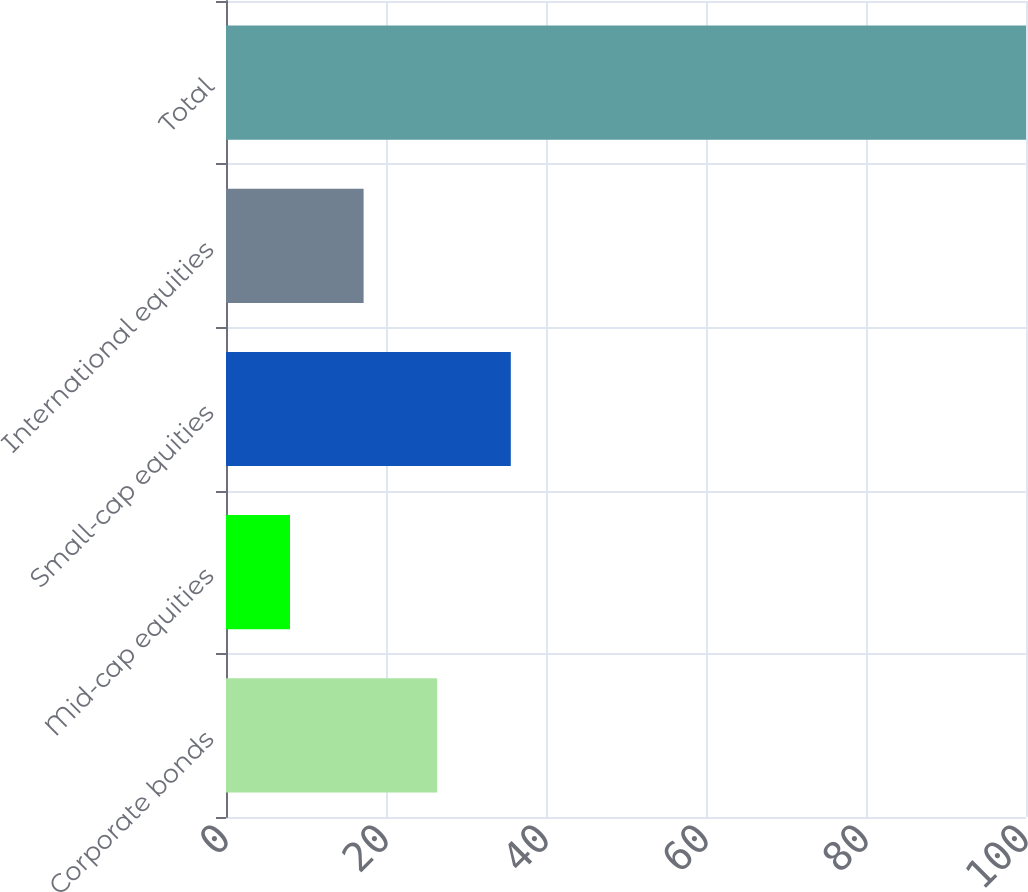Convert chart to OTSL. <chart><loc_0><loc_0><loc_500><loc_500><bar_chart><fcel>Corporate bonds<fcel>Mid-cap equities<fcel>Small-cap equities<fcel>International equities<fcel>Total<nl><fcel>26.4<fcel>8<fcel>35.6<fcel>17.2<fcel>100<nl></chart> 